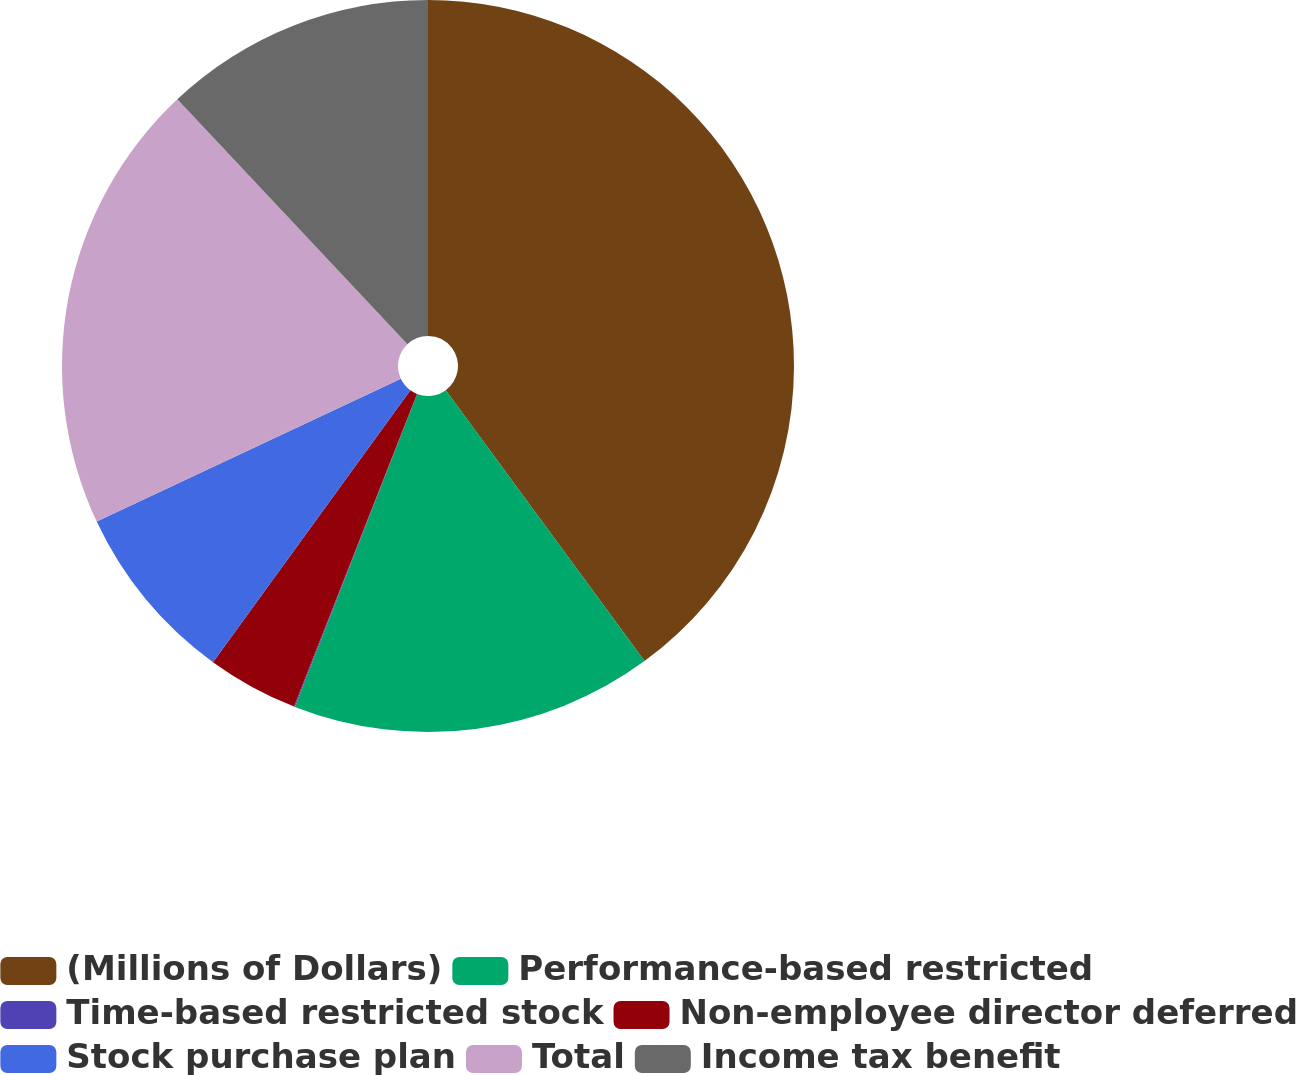Convert chart to OTSL. <chart><loc_0><loc_0><loc_500><loc_500><pie_chart><fcel>(Millions of Dollars)<fcel>Performance-based restricted<fcel>Time-based restricted stock<fcel>Non-employee director deferred<fcel>Stock purchase plan<fcel>Total<fcel>Income tax benefit<nl><fcel>39.93%<fcel>16.0%<fcel>0.04%<fcel>4.03%<fcel>8.02%<fcel>19.98%<fcel>12.01%<nl></chart> 